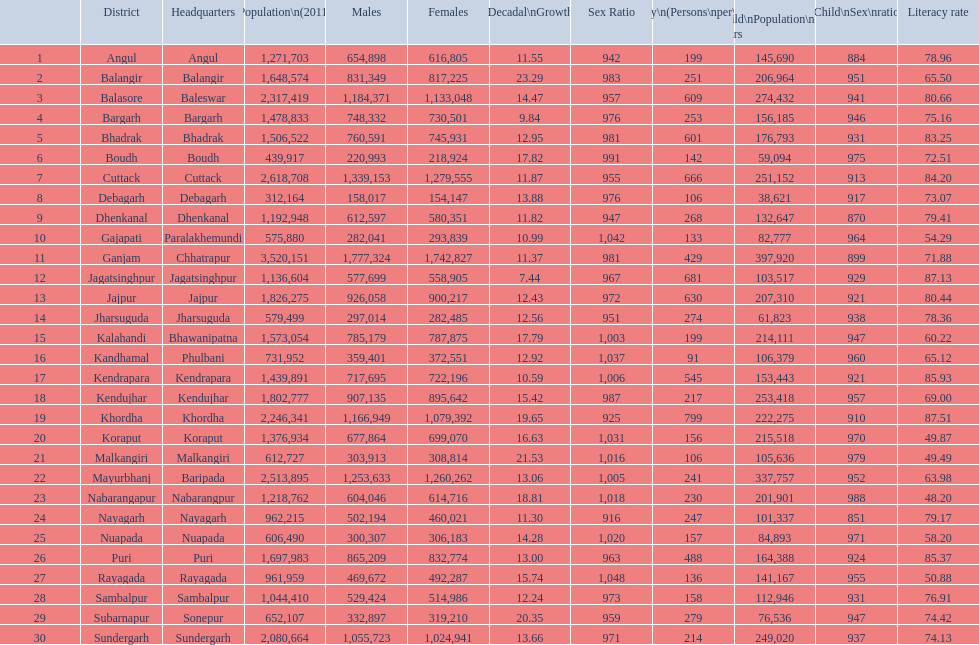Parse the table in full. {'header': ['', 'District', 'Headquarters', 'Population\\n(2011)', 'Males', 'Females', 'Percentage\\nDecadal\\nGrowth\\n2001-2011', 'Sex Ratio', 'Density\\n(Persons\\nper\\nkm2)', 'Child\\nPopulation\\n0–6 years', 'Child\\nSex\\nratio', 'Literacy rate'], 'rows': [['1', 'Angul', 'Angul', '1,271,703', '654,898', '616,805', '11.55', '942', '199', '145,690', '884', '78.96'], ['2', 'Balangir', 'Balangir', '1,648,574', '831,349', '817,225', '23.29', '983', '251', '206,964', '951', '65.50'], ['3', 'Balasore', 'Baleswar', '2,317,419', '1,184,371', '1,133,048', '14.47', '957', '609', '274,432', '941', '80.66'], ['4', 'Bargarh', 'Bargarh', '1,478,833', '748,332', '730,501', '9.84', '976', '253', '156,185', '946', '75.16'], ['5', 'Bhadrak', 'Bhadrak', '1,506,522', '760,591', '745,931', '12.95', '981', '601', '176,793', '931', '83.25'], ['6', 'Boudh', 'Boudh', '439,917', '220,993', '218,924', '17.82', '991', '142', '59,094', '975', '72.51'], ['7', 'Cuttack', 'Cuttack', '2,618,708', '1,339,153', '1,279,555', '11.87', '955', '666', '251,152', '913', '84.20'], ['8', 'Debagarh', 'Debagarh', '312,164', '158,017', '154,147', '13.88', '976', '106', '38,621', '917', '73.07'], ['9', 'Dhenkanal', 'Dhenkanal', '1,192,948', '612,597', '580,351', '11.82', '947', '268', '132,647', '870', '79.41'], ['10', 'Gajapati', 'Paralakhemundi', '575,880', '282,041', '293,839', '10.99', '1,042', '133', '82,777', '964', '54.29'], ['11', 'Ganjam', 'Chhatrapur', '3,520,151', '1,777,324', '1,742,827', '11.37', '981', '429', '397,920', '899', '71.88'], ['12', 'Jagatsinghpur', 'Jagatsinghpur', '1,136,604', '577,699', '558,905', '7.44', '967', '681', '103,517', '929', '87.13'], ['13', 'Jajpur', 'Jajpur', '1,826,275', '926,058', '900,217', '12.43', '972', '630', '207,310', '921', '80.44'], ['14', 'Jharsuguda', 'Jharsuguda', '579,499', '297,014', '282,485', '12.56', '951', '274', '61,823', '938', '78.36'], ['15', 'Kalahandi', 'Bhawanipatna', '1,573,054', '785,179', '787,875', '17.79', '1,003', '199', '214,111', '947', '60.22'], ['16', 'Kandhamal', 'Phulbani', '731,952', '359,401', '372,551', '12.92', '1,037', '91', '106,379', '960', '65.12'], ['17', 'Kendrapara', 'Kendrapara', '1,439,891', '717,695', '722,196', '10.59', '1,006', '545', '153,443', '921', '85.93'], ['18', 'Kendujhar', 'Kendujhar', '1,802,777', '907,135', '895,642', '15.42', '987', '217', '253,418', '957', '69.00'], ['19', 'Khordha', 'Khordha', '2,246,341', '1,166,949', '1,079,392', '19.65', '925', '799', '222,275', '910', '87.51'], ['20', 'Koraput', 'Koraput', '1,376,934', '677,864', '699,070', '16.63', '1,031', '156', '215,518', '970', '49.87'], ['21', 'Malkangiri', 'Malkangiri', '612,727', '303,913', '308,814', '21.53', '1,016', '106', '105,636', '979', '49.49'], ['22', 'Mayurbhanj', 'Baripada', '2,513,895', '1,253,633', '1,260,262', '13.06', '1,005', '241', '337,757', '952', '63.98'], ['23', 'Nabarangapur', 'Nabarangpur', '1,218,762', '604,046', '614,716', '18.81', '1,018', '230', '201,901', '988', '48.20'], ['24', 'Nayagarh', 'Nayagarh', '962,215', '502,194', '460,021', '11.30', '916', '247', '101,337', '851', '79.17'], ['25', 'Nuapada', 'Nuapada', '606,490', '300,307', '306,183', '14.28', '1,020', '157', '84,893', '971', '58.20'], ['26', 'Puri', 'Puri', '1,697,983', '865,209', '832,774', '13.00', '963', '488', '164,388', '924', '85.37'], ['27', 'Rayagada', 'Rayagada', '961,959', '469,672', '492,287', '15.74', '1,048', '136', '141,167', '955', '50.88'], ['28', 'Sambalpur', 'Sambalpur', '1,044,410', '529,424', '514,986', '12.24', '973', '158', '112,946', '931', '76.91'], ['29', 'Subarnapur', 'Sonepur', '652,107', '332,897', '319,210', '20.35', '959', '279', '76,536', '947', '74.42'], ['30', 'Sundergarh', 'Sundergarh', '2,080,664', '1,055,723', '1,024,941', '13.66', '971', '214', '249,020', '937', '74.13']]} In which district was the population density the highest per square kilometer? Khordha. 